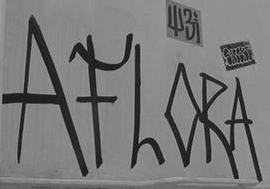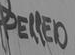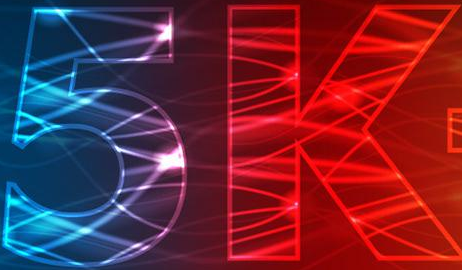Read the text from these images in sequence, separated by a semicolon. AFLORA; PELLED; 5k 